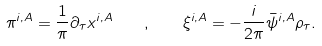Convert formula to latex. <formula><loc_0><loc_0><loc_500><loc_500>\pi ^ { i , A } = \frac { 1 } { \pi } \partial _ { \tau } x ^ { i , A } \quad , \quad \xi ^ { i , A } = - \frac { i } { 2 \pi } \bar { \psi } ^ { i , A } \rho _ { \tau } .</formula> 